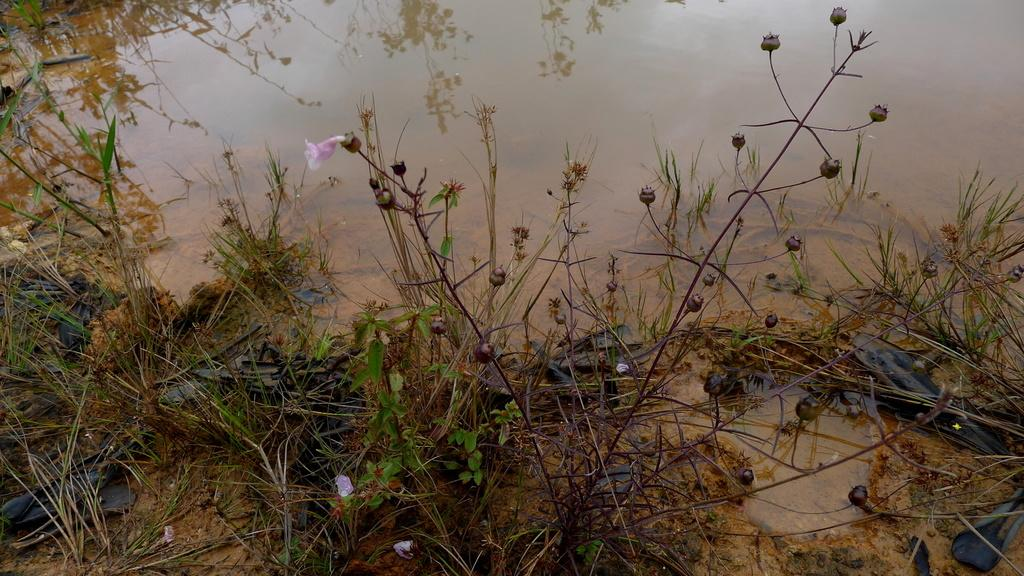What type of vegetation can be seen in the image? There are flowers on the plants in the image. Are there any signs of growth on the plants? Yes, there are buds on the plants in the image. What type of ground is visible in the image? There is grass visible in the image. What is present at the bottom of the image? There is mud at the bottom of the image. What else can be seen in the image besides the plants? There is water visible in the image. What can be observed on the water's surface in the image? There are reflections of plants on the water in the image. How many weeks has the grandfather been away from the image? There is no mention of a grandfather or any time-related information in the image, so this question cannot be answered. 